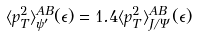Convert formula to latex. <formula><loc_0><loc_0><loc_500><loc_500>\langle p _ { T } ^ { 2 } \rangle _ { \psi ^ { \prime } } ^ { A B } ( \epsilon ) = 1 . 4 \langle p _ { T } ^ { 2 } \rangle _ { J / \Psi } ^ { A B } ( \epsilon )</formula> 